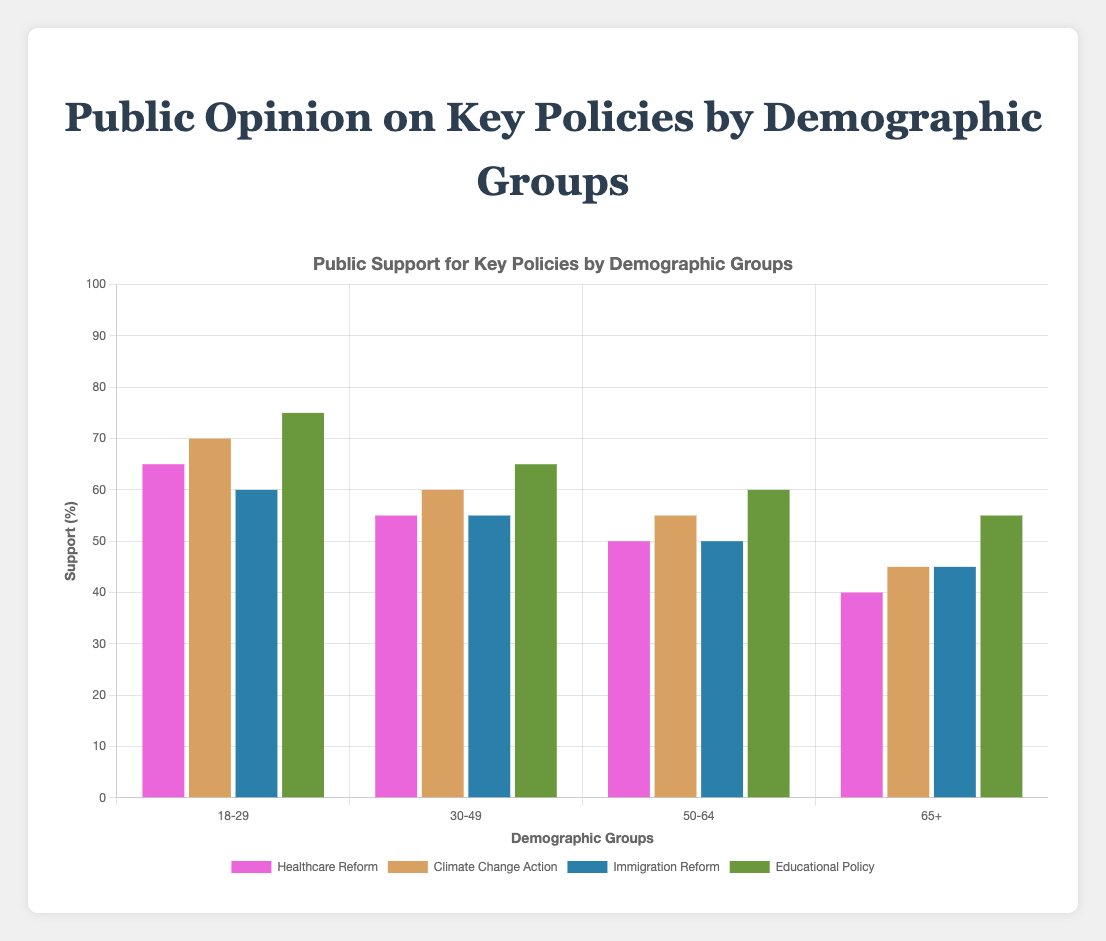Which demographic group shows the highest support for Educational Policy? The bars in the chart show the height of support percentages for Educational Policy across all demographic groups. The tallest bar for Educational Policy indicates the highest support, which is seen in the 18-29 group with 75% support.
Answer: 18-29 How does support for Healthcare Reform differ between the 18-29 and 65+ age groups? To determine the difference in support for Healthcare Reform, subtract the support percentage of the 65+ group from the support percentage of the 18-29 group. This is calculated as 65% - 40% = 25%.
Answer: 25% What is the average support for Climate Change Action across all demographic groups? Add the support percentages for all demographic groups for Climate Change Action and divide by the number of groups: (70+60+55+45) / 4 = 230 / 4 = 57.5%.
Answer: 57.5% Which policy has the least support among the 50-64 age group? Compare the support percentages of all policies for the 50-64 age group. Healthcare Reform has 50%, Climate Change Action has 55%, Immigration Reform has 50%, and Educational Policy has 60%. The least support is for Healthcare Reform and Immigration Reform, both at 50%.
Answer: Healthcare Reform and Immigration Reform Between Immigration Reform and Healthcare Reform, which policy has more support among the 30-49 age group? Compare the support percentages for Immigration Reform and Healthcare Reform in the 30-49 group. Immigration Reform has 55% support while Healthcare Reform has 55% support. It turns out they have equal support.
Answer: Equal support What is the sum of the percentages of opposition to Climate Change Action in the 18-29 and 65+ demographic groups? Add the opposition percentages for Climate Change Action in the 18-29 and 65+ groups. This is calculated as 20% + 45% = 65%.
Answer: 65% Which demographic group shows the greatest variability in support for different policies? Looking at the chart, calculate the range (maximum - minimum support) for each demographic group across all policies. Greater range indicates greater variability.
Answer: 65+ What is the median support for Immigration Reform across all demographic groups? Order the support percentages for Immigration Reform and find the middle value. The percentages are 60%, 55%, 50%, and 45%. The median is the average of the two middle values: (55+50)/2 = 52.5%.
Answer: 52.5% Which policy has the highest average support across all demographic groups? Calculate the average support for each policy by adding support percentages across all demographic groups and dividing by the number of groups:
- Healthcare Reform: (65+55+50+40) / 4 = 52.5%
- Climate Change Action: (70+60+55+45) / 4 = 57.5%
- Immigration Reform: (60+55+50+45) / 4 = 52.5%
- Educational Policy: (75+65+60+55) / 4 = 63.75%. The highest average is for Educational Policy.
Answer: Educational Policy 